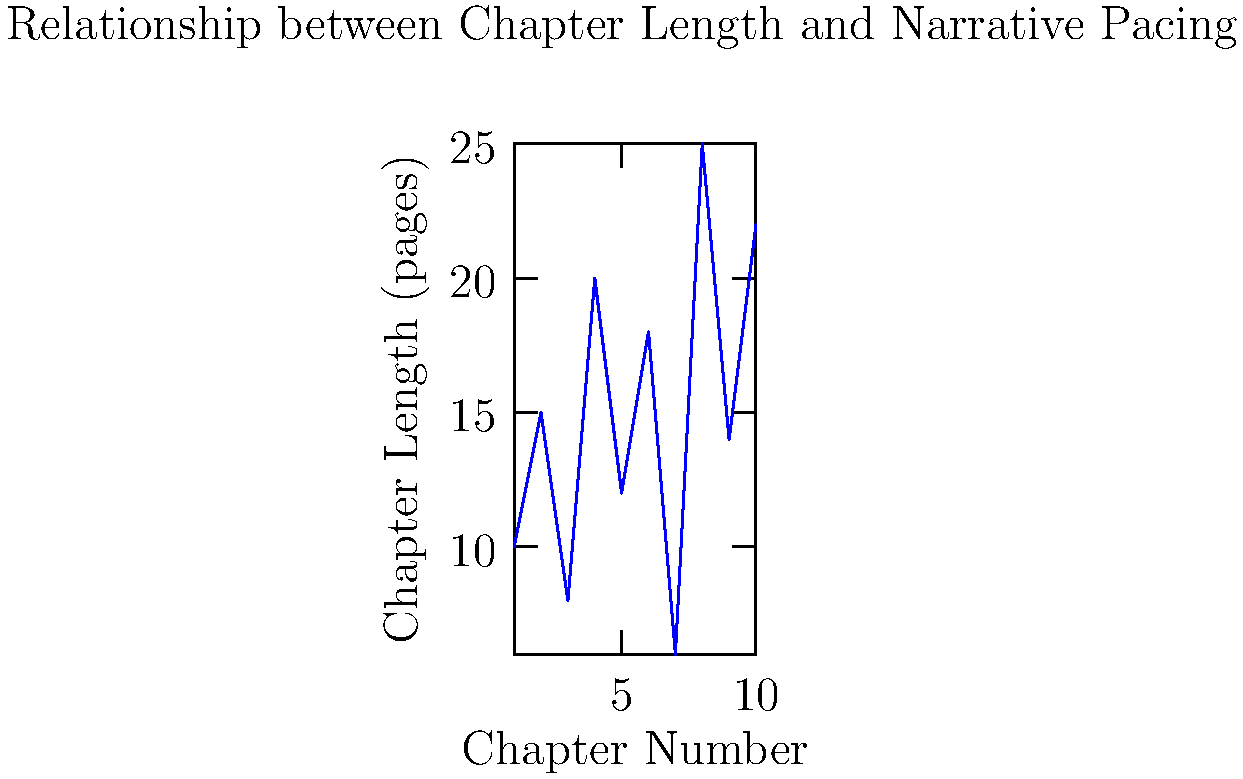Analyze the line graph depicting the relationship between chapter length and chapter number in a novel. How might this pattern of varying chapter lengths influence the narrative pacing and reader engagement throughout the book? Consider how a novelist might use this technique to manipulate the story's rhythm and emotional impact. 1. Observe the overall pattern: The graph shows significant variations in chapter length across the novel.

2. Identify key points:
   - Shortest chapters: Chapters 3 and 7 (8 and 6 pages respectively)
   - Longest chapters: Chapters 8 and 10 (25 and 22 pages respectively)

3. Analyze the rhythm:
   - The alternating pattern of short and long chapters creates a dynamic reading experience.
   - Short chapters (3, 7) may indicate fast-paced action or quick scene changes.
   - Longer chapters (4, 8, 10) suggest more detailed exposition or complex plot developments.

4. Consider the narrative impact:
   - Varying chapter lengths can control the story's tempo, creating tension and release.
   - Short chapters might build suspense or create cliffhangers.
   - Longer chapters allow for deeper character development or world-building.

5. Examine the emotional journey:
   - The irregular pattern mirrors the ebb and flow of emotions in the story.
   - Rapid changes in chapter length could reflect sudden plot twists or shifts in perspective.

6. Reflect on reader engagement:
   - Diverse chapter lengths prevent monotony and maintain reader interest.
   - Short chapters provide natural stopping points, while longer ones encourage extended reading sessions.

7. Consider the novelist's intent:
   - This structural choice likely aims to enhance the story's impact through pacing.
   - The author may be using chapter length as a subtle tool to guide the reader's experience and interpretation of events.
Answer: Varying chapter lengths create a dynamic narrative rhythm, manipulating pacing and reader engagement through alternating periods of tension and exposition. 